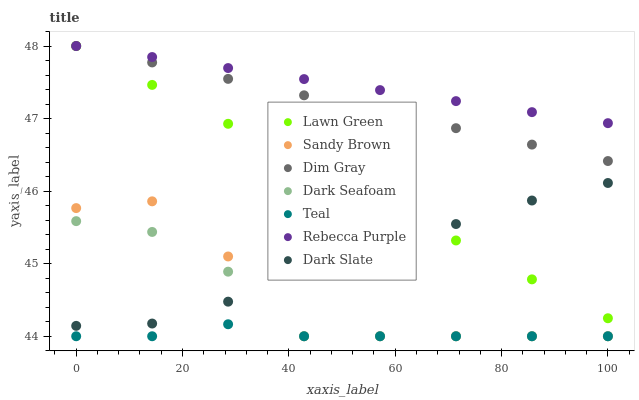Does Teal have the minimum area under the curve?
Answer yes or no. Yes. Does Rebecca Purple have the maximum area under the curve?
Answer yes or no. Yes. Does Dim Gray have the minimum area under the curve?
Answer yes or no. No. Does Dim Gray have the maximum area under the curve?
Answer yes or no. No. Is Rebecca Purple the smoothest?
Answer yes or no. Yes. Is Sandy Brown the roughest?
Answer yes or no. Yes. Is Dim Gray the smoothest?
Answer yes or no. No. Is Dim Gray the roughest?
Answer yes or no. No. Does Dark Seafoam have the lowest value?
Answer yes or no. Yes. Does Dim Gray have the lowest value?
Answer yes or no. No. Does Rebecca Purple have the highest value?
Answer yes or no. Yes. Does Dark Slate have the highest value?
Answer yes or no. No. Is Sandy Brown less than Rebecca Purple?
Answer yes or no. Yes. Is Dim Gray greater than Teal?
Answer yes or no. Yes. Does Dark Seafoam intersect Dark Slate?
Answer yes or no. Yes. Is Dark Seafoam less than Dark Slate?
Answer yes or no. No. Is Dark Seafoam greater than Dark Slate?
Answer yes or no. No. Does Sandy Brown intersect Rebecca Purple?
Answer yes or no. No. 